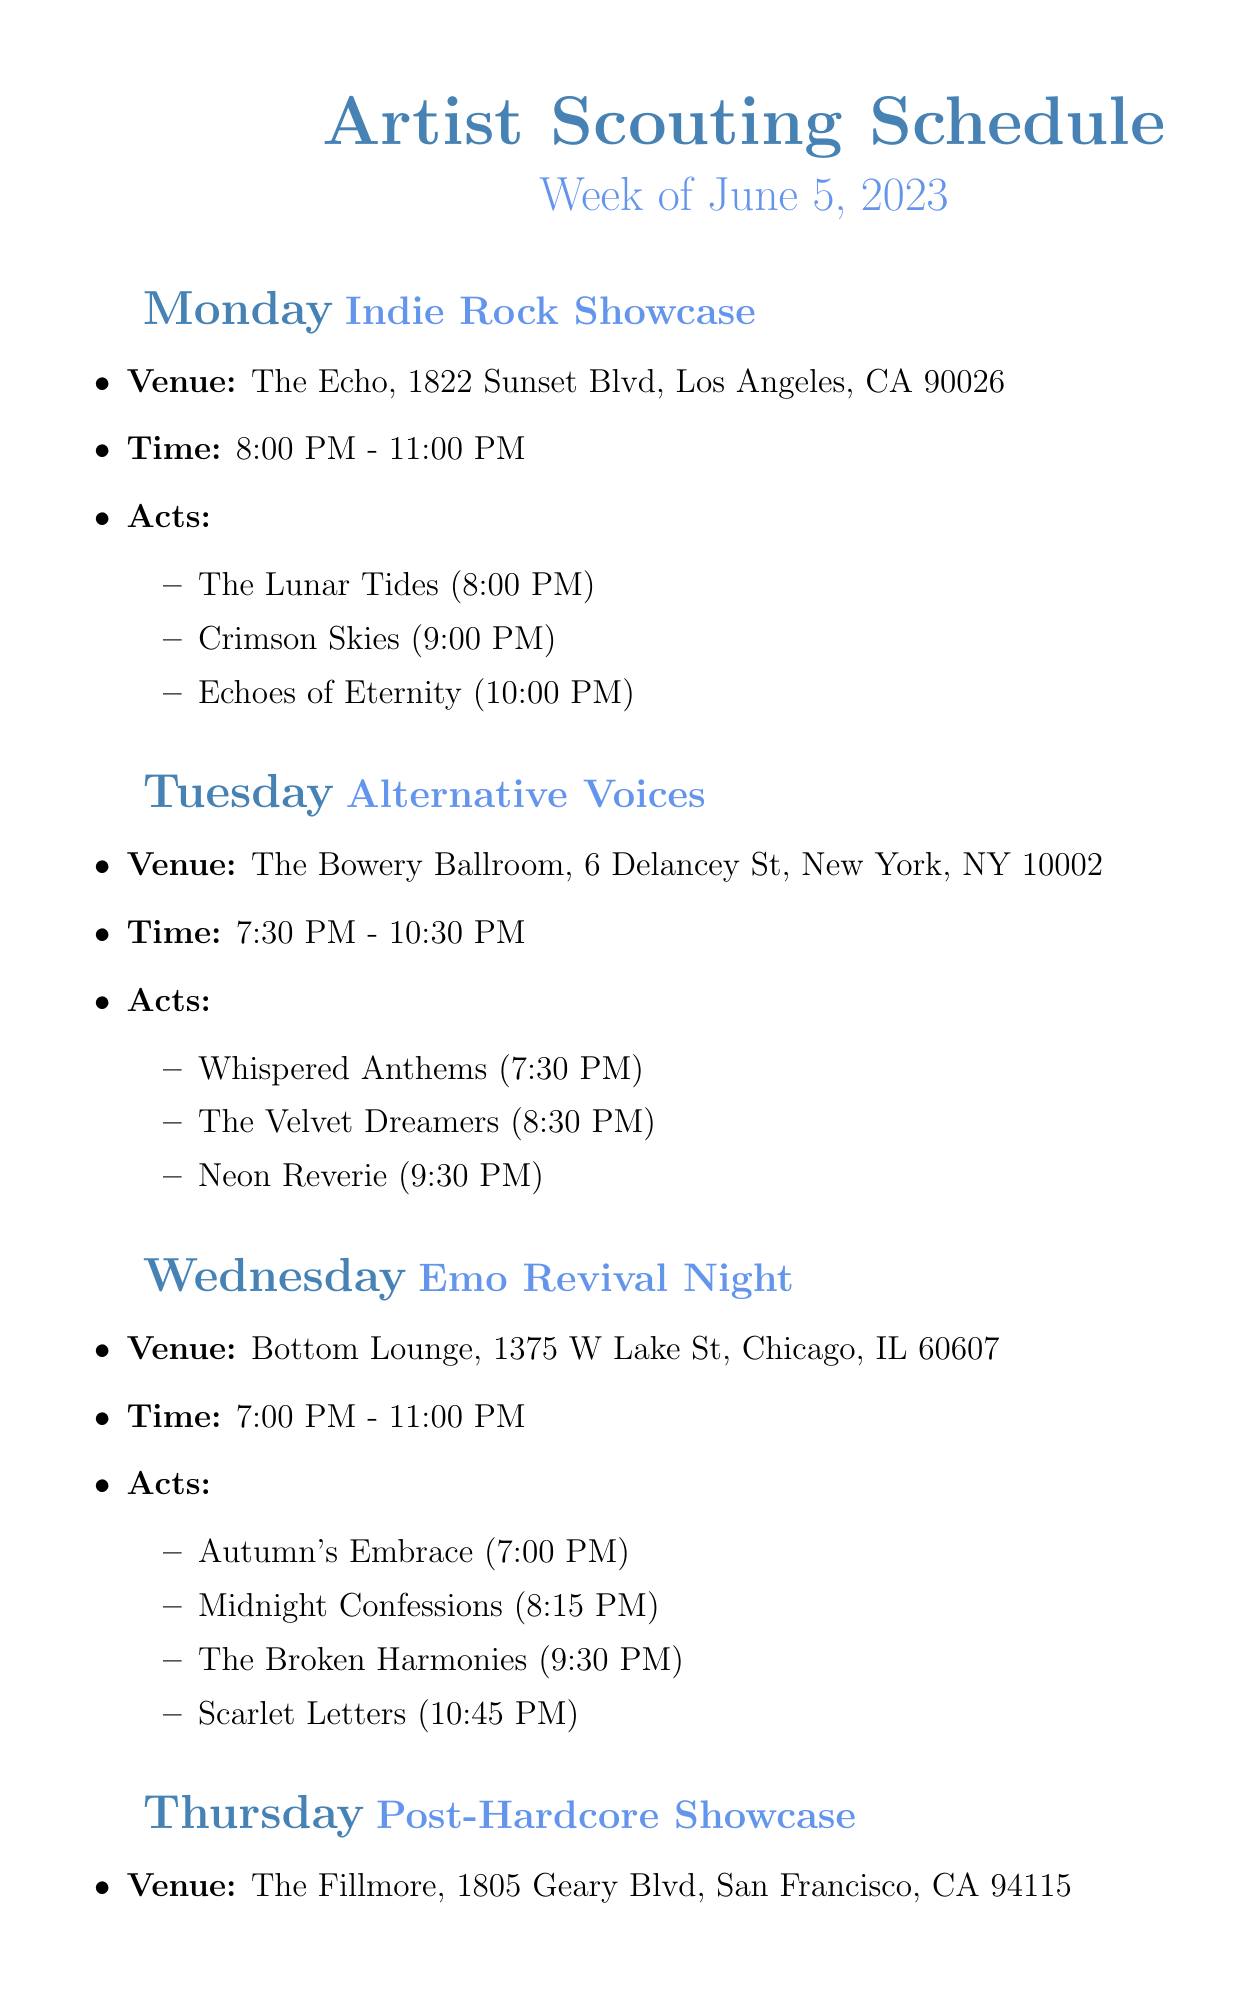What is the venue for the Indie Rock Showcase? The venue for the Indie Rock Showcase is listed in the document.
Answer: The Echo What is the performance time for Whispered Anthems? The performance time of Whispered Anthems is specified in the document.
Answer: 7:30 PM Which day has the event titled "Emo Revival Night"? The document outlines events by day, and Emo Revival Night is listed under Wednesday.
Answer: Wednesday What is the address of The Fillmore? The address of The Fillmore is detailed in the event description.
Answer: 1805 Geary Blvd, San Francisco, CA 94115 How many acts perform during the Indie Label Showcase? The number of acts can be counted from the event details in the document.
Answer: 5 What time does the Acoustic Sessions start? The start time of the Acoustic Sessions can be found in the event details.
Answer: 7:00 PM Which event has Scarlet Letters performing? The event featuring Scarlet Letters is mentioned in the document.
Answer: Emo Revival Night What is the ending time for the Post-Hardcore Showcase? The ending time for the event is included in the details.
Answer: 11:30 PM Which city hosts the Experimental Rock Night? The city for the Experimental Rock Night is provided in the venue details.
Answer: Boston 